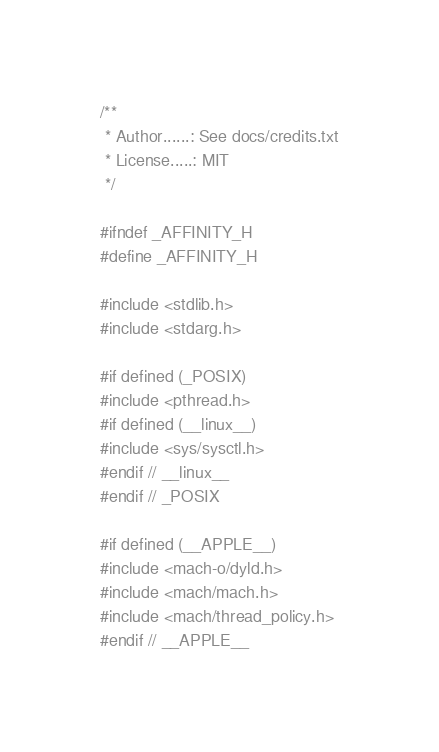Convert code to text. <code><loc_0><loc_0><loc_500><loc_500><_C_>/**
 * Author......: See docs/credits.txt
 * License.....: MIT
 */

#ifndef _AFFINITY_H
#define _AFFINITY_H

#include <stdlib.h>
#include <stdarg.h>

#if defined (_POSIX)
#include <pthread.h>
#if defined (__linux__)
#include <sys/sysctl.h>
#endif // __linux__
#endif // _POSIX

#if defined (__APPLE__)
#include <mach-o/dyld.h>
#include <mach/mach.h>
#include <mach/thread_policy.h>
#endif // __APPLE__
</code> 